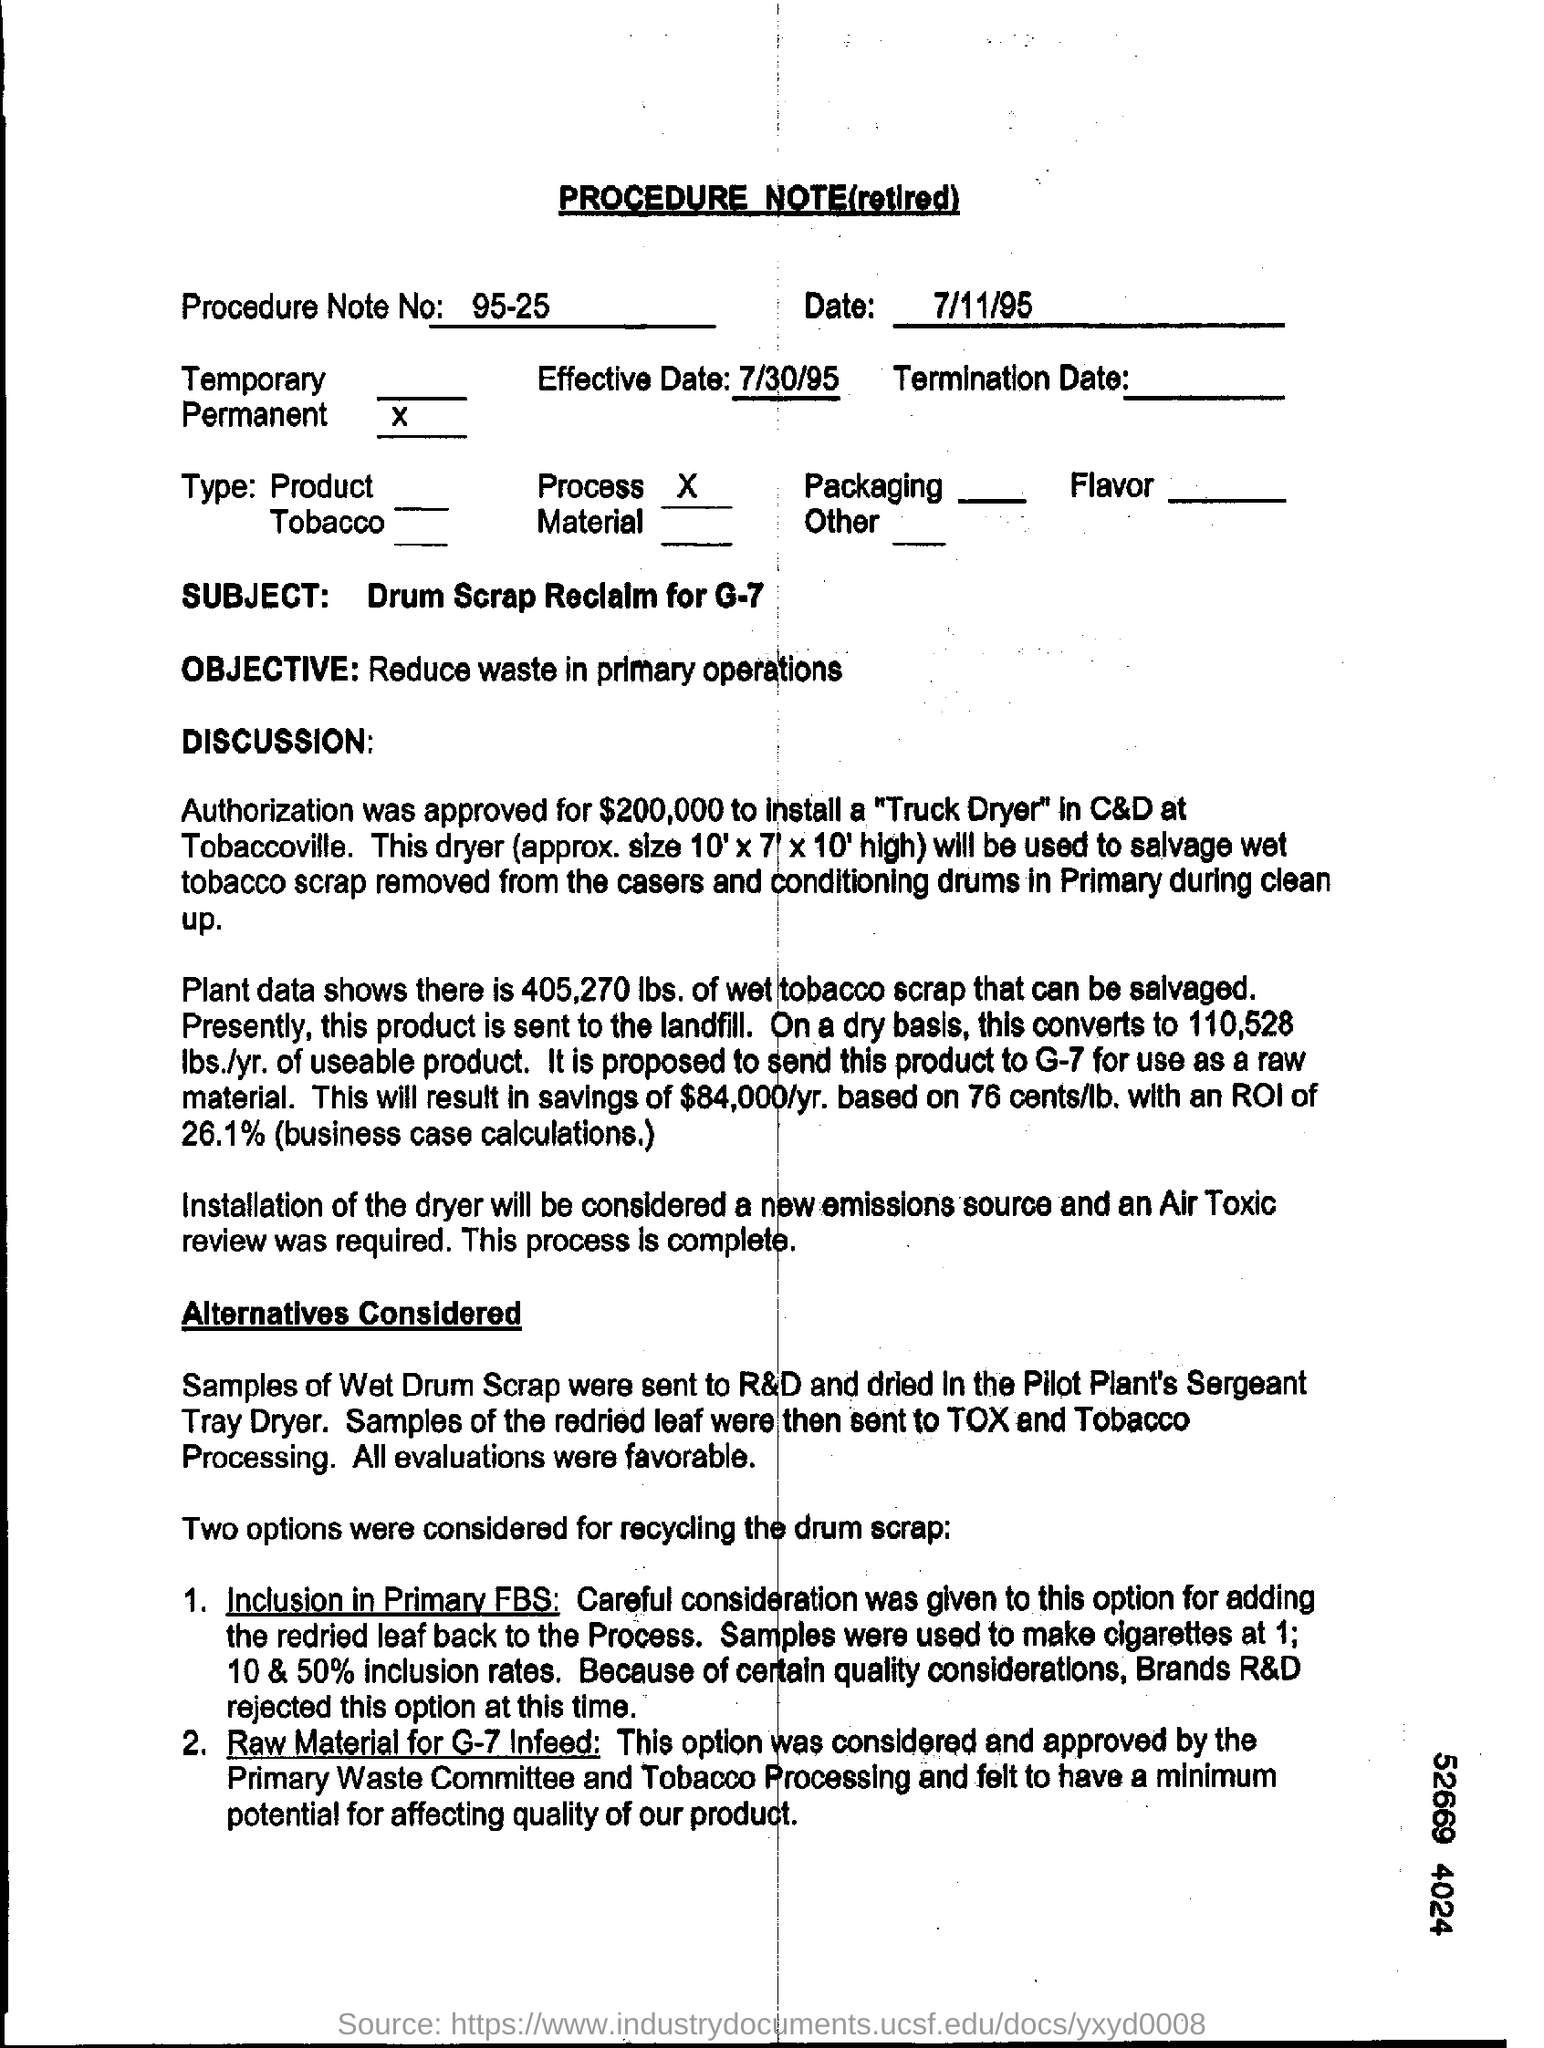What kind of document is this?
Your answer should be compact. PROCEDURE NOTE(retired). What is the Effective Date mentioned in the procedure note?
Your response must be concise. 7/30/95. What is the Procedure Note No of the given document?
Offer a terse response. 95-25. What is the subject mentioned in the procedure note?
Offer a terse response. Drum Scrap Reclalm for G-7. What is the objective as per the document?
Keep it short and to the point. Reduce waste in primary operations. As per the plant data , how much lbs. of wet tobacco scrap can be salvaged?
Your answer should be compact. 405,270. 